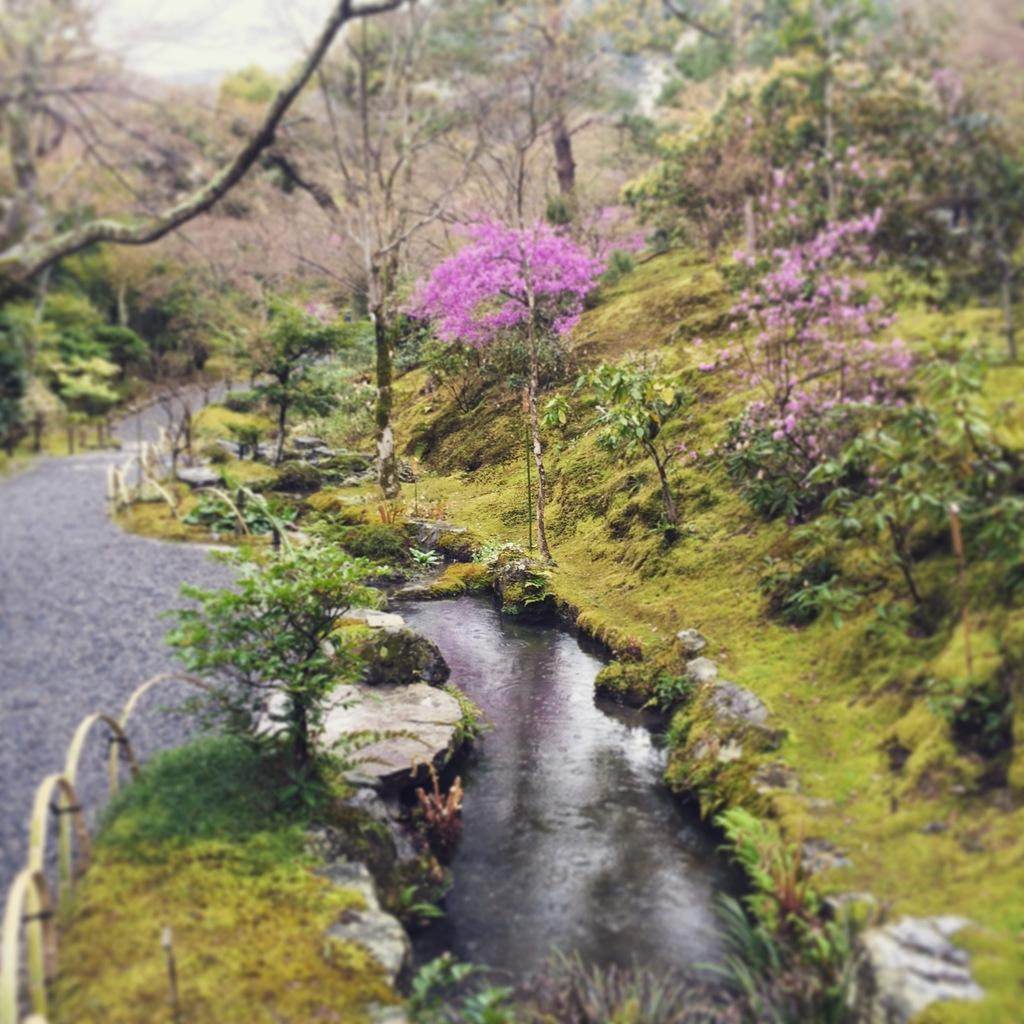What natural element is visible in the image? Water is visible in the image. What type of man-made structure can be seen in the image? There is a road in the image. What type of vegetation is present in the image? There are trees, plants, and grass in the image. What part of the natural environment is visible in the image? The sky is visible in the background of the image. What type of hair can be seen on the trees in the image? Trees do not have hair; they have leaves or needles. What type of crook is visible in the image? There is no crook present in the image. 